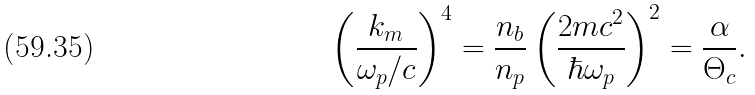Convert formula to latex. <formula><loc_0><loc_0><loc_500><loc_500>\left ( \frac { k _ { m } } { \omega _ { p } / c } \right ) ^ { 4 } = \frac { n _ { b } } { n _ { p } } \left ( \frac { 2 m c ^ { 2 } } { \hbar { \omega } _ { p } } \right ) ^ { 2 } = \frac { \alpha } { \Theta _ { c } } .</formula> 